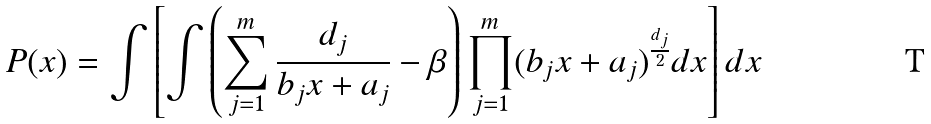Convert formula to latex. <formula><loc_0><loc_0><loc_500><loc_500>P ( x ) = \int \left [ \int \left ( \sum _ { j = 1 } ^ { m } \frac { d _ { j } } { b _ { j } x + a _ { j } } - \beta \right ) \prod _ { j = 1 } ^ { m } ( b _ { j } x + a _ { j } ) ^ { \frac { d _ { j } } { 2 } } d x \right ] d x</formula> 